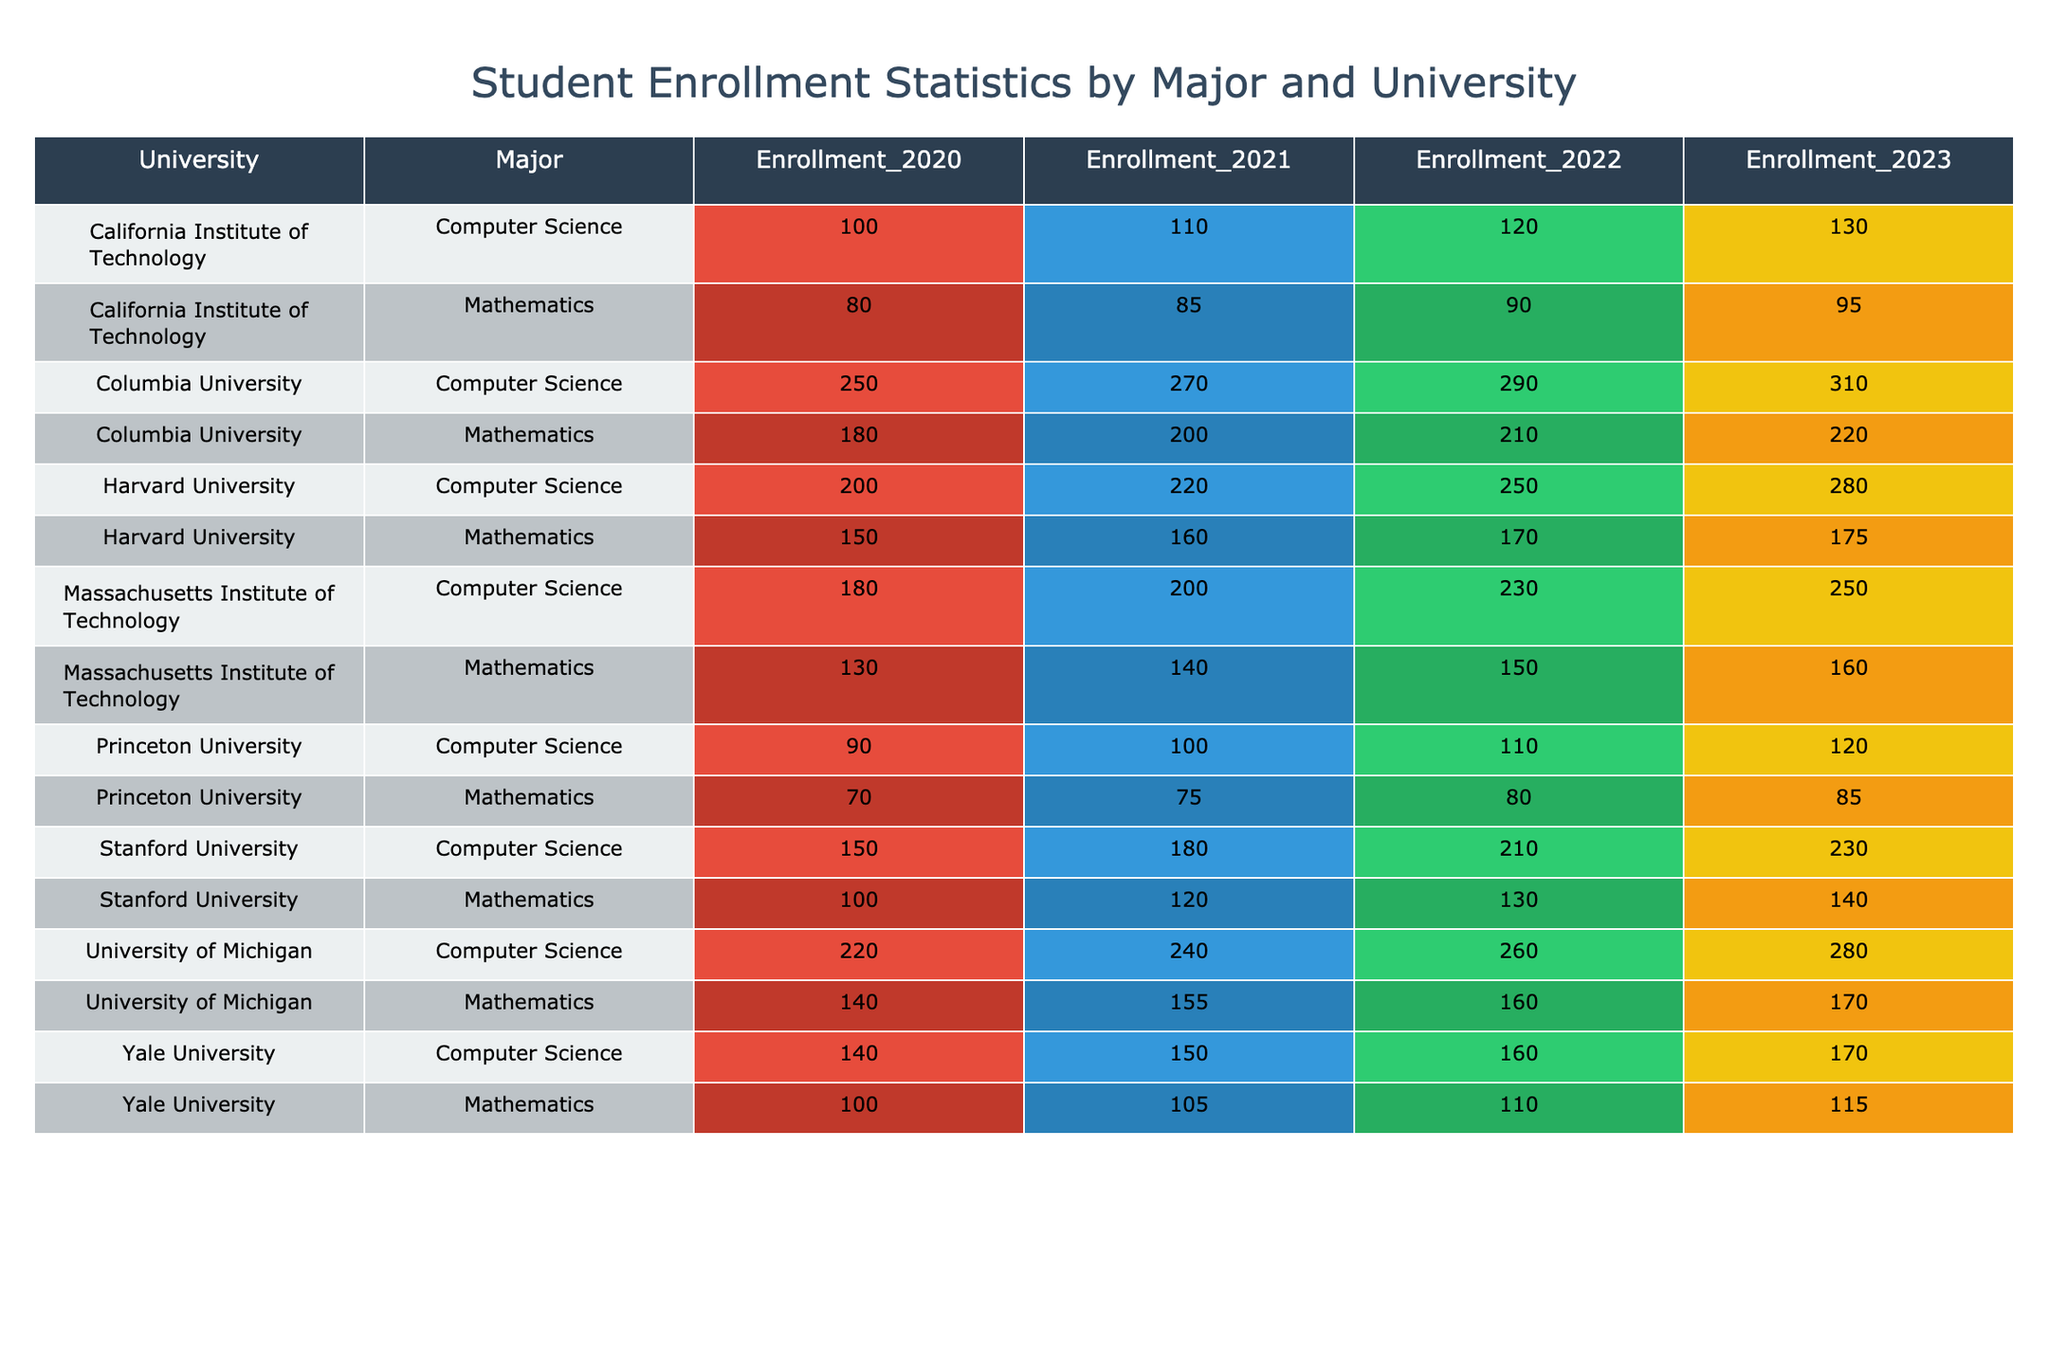What was the enrollment for Computer Science at Columbia University in 2022? From the table, we look for the row corresponding to Columbia University and Computer Science, where the value for the year 2022 shows the enrollment number, which is 290.
Answer: 290 Which university had the highest enrollment in Mathematics in 2023? Looking at the Mathematics enrollment values for the year 2023, we compare the values: Harvard (175), Stanford (140), MIT (160), Michigan (170), Caltech (95), Princeton (85), Columbia (220), and Yale (115). Columbia University has the highest enrollment at 220.
Answer: Columbia University What is the total enrollment for Computer Science across all universities in 2021? The enrollment numbers for Computer Science in 2021 are 220 (Harvard) + 180 (Stanford) + 200 (MIT) + 240 (Michigan) + 110 (Caltech) + 100 (Princeton) + 270 (Columbia) + 150 (Yale). Summing these gives a total of 220 + 180 + 200 + 240 + 110 + 100 + 270 + 150 = 1,480.
Answer: 1480 Did Yale University have more Mathematics students than Princeton University in 2022? We check the Mathematics enrollment for Yale (110) and Princeton (80) in 2022. Since 110 is greater than 80, the statement is true.
Answer: Yes What is the average enrollment for Mathematics across all universities in 2023? The enrollments for Mathematics in 2023 are: Harvard (175), Stanford (140), MIT (160), Michigan (170), Caltech (95), Princeton (85), Columbia (220), and Yale (115). Summing these gives 175 + 140 + 160 + 170 + 95 + 85 + 220 + 115 = 1,150. There are 8 universities, so the average is 1,150 / 8 = 143.75.
Answer: 143.75 Which major had the highest total enrollment from 2020 to 2023 combined? Calculating the total enrollments for Computer Science from 2020 to 2023: 200 + 220 + 250 + 280 = 950. For Mathematics: 150 + 160 + 170 + 175 = 655. Computer Science has a higher total of 950 compared to Mathematics' total of 655.
Answer: Computer Science What was the difference in enrollment for Computer Science between MIT in 2020 and Stanford in 2023? The enrollment for MIT in 2020 is 180, and for Stanford in 2023, it is 230. The difference is 230 - 180 = 50.
Answer: 50 Which university saw the largest increase in Computer Science enrollment from 2020 to 2023? We calculate the increase for each university: Harvard (80), Stanford (80), MIT (70), Michigan (60), Caltech (30), Princeton (30), Columbia (60), and Yale (30). The largest increase is 80 for both Harvard and Stanford.
Answer: Harvard and Stanford Were more students enrolled in Computer Science at the University of Michigan than Harvard University in 2022? The enrollment for University of Michigan in Computer Science is 260, while for Harvard it is 250 in the same year. Since 260 is greater than 250, the answer is true.
Answer: Yes 